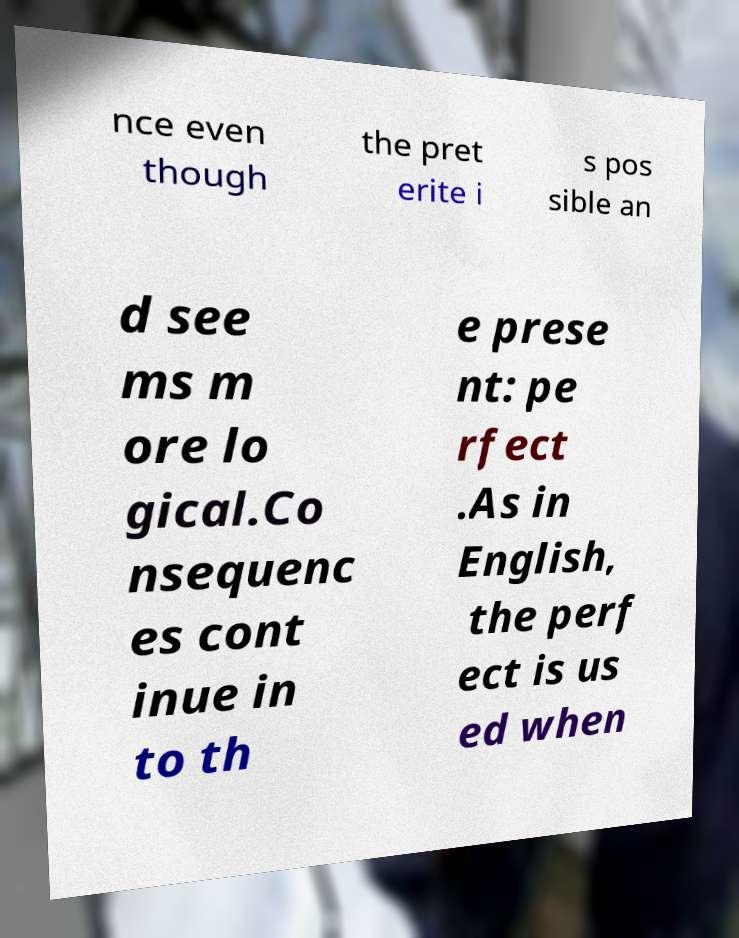Could you assist in decoding the text presented in this image and type it out clearly? nce even though the pret erite i s pos sible an d see ms m ore lo gical.Co nsequenc es cont inue in to th e prese nt: pe rfect .As in English, the perf ect is us ed when 